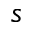Convert formula to latex. <formula><loc_0><loc_0><loc_500><loc_500>s</formula> 